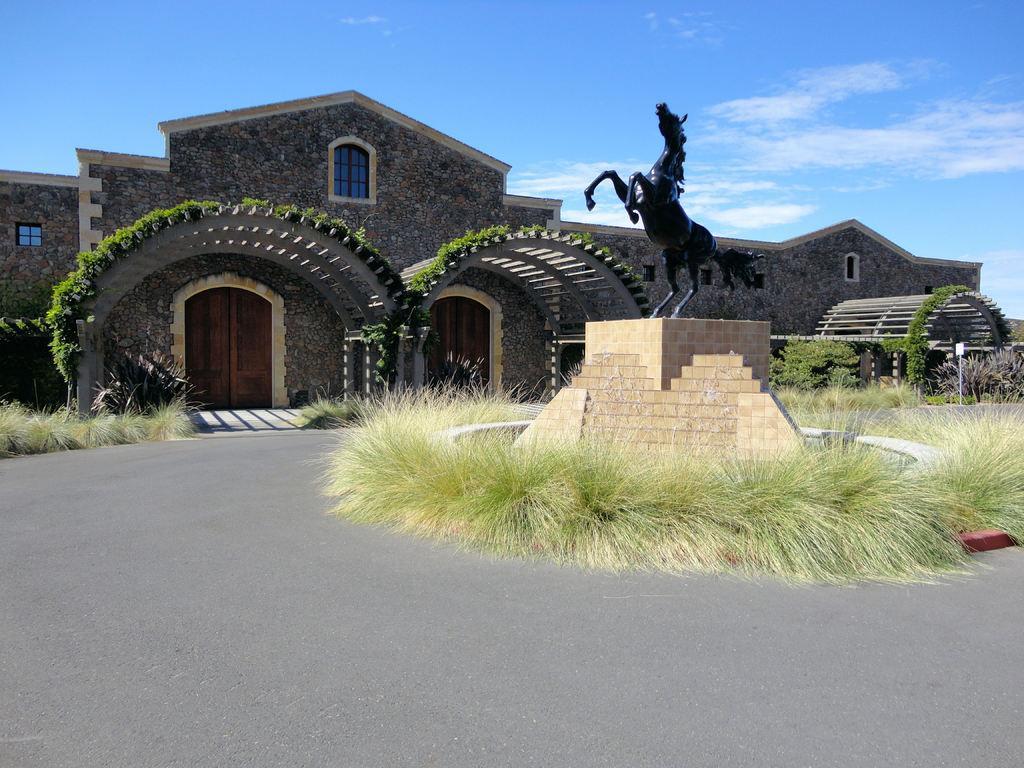Please provide a concise description of this image. This picture is clicked outside. On the right we can see the sculpture of a horse and we can see the grass and some plants. In the center we can see the windows and doors of the houses and some other objects. 